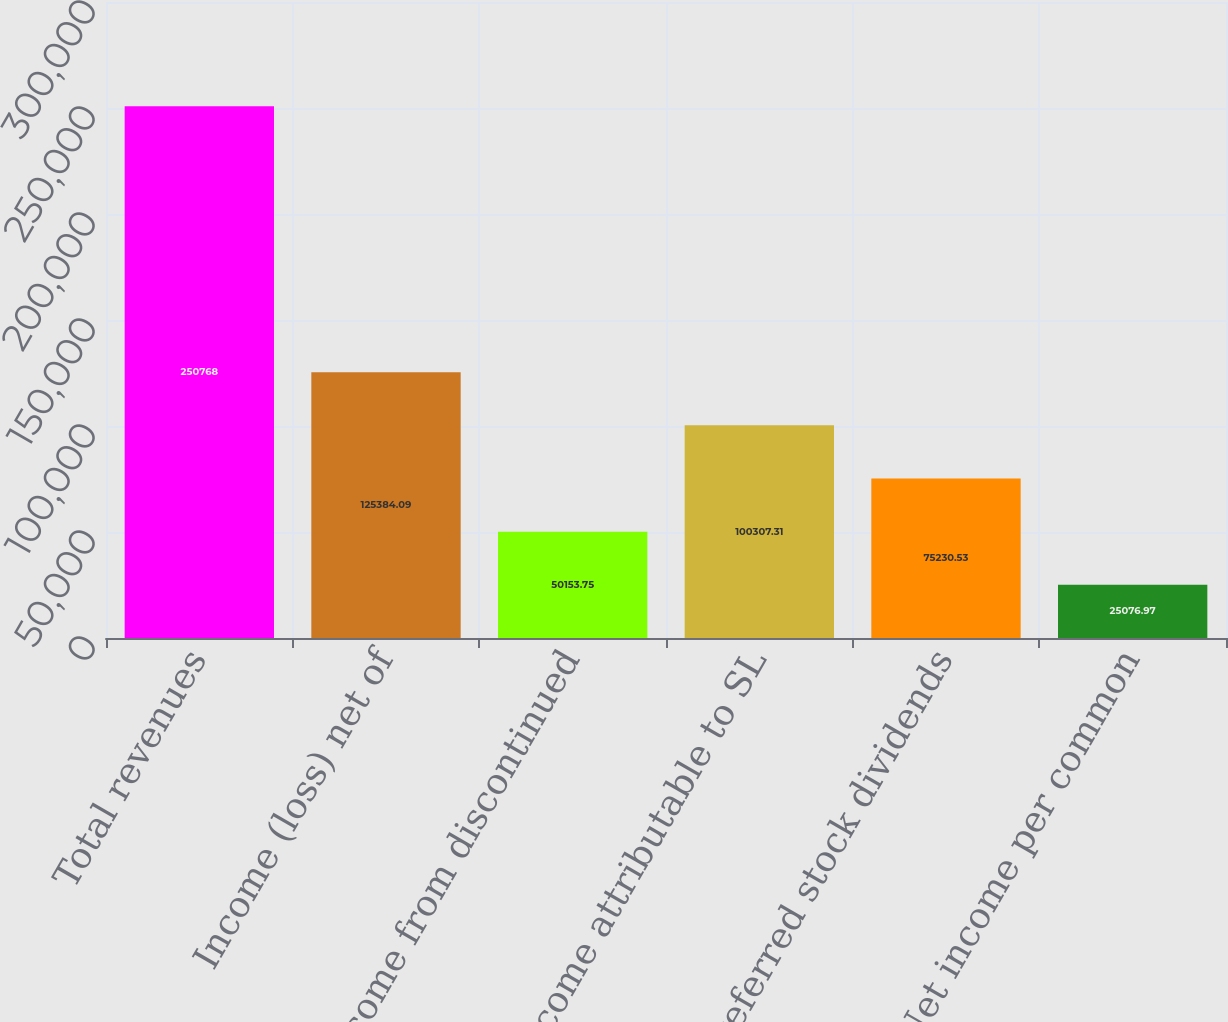Convert chart. <chart><loc_0><loc_0><loc_500><loc_500><bar_chart><fcel>Total revenues<fcel>Income (loss) net of<fcel>Net income from discontinued<fcel>Net income attributable to SL<fcel>Preferred stock dividends<fcel>Net income per common<nl><fcel>250768<fcel>125384<fcel>50153.8<fcel>100307<fcel>75230.5<fcel>25077<nl></chart> 